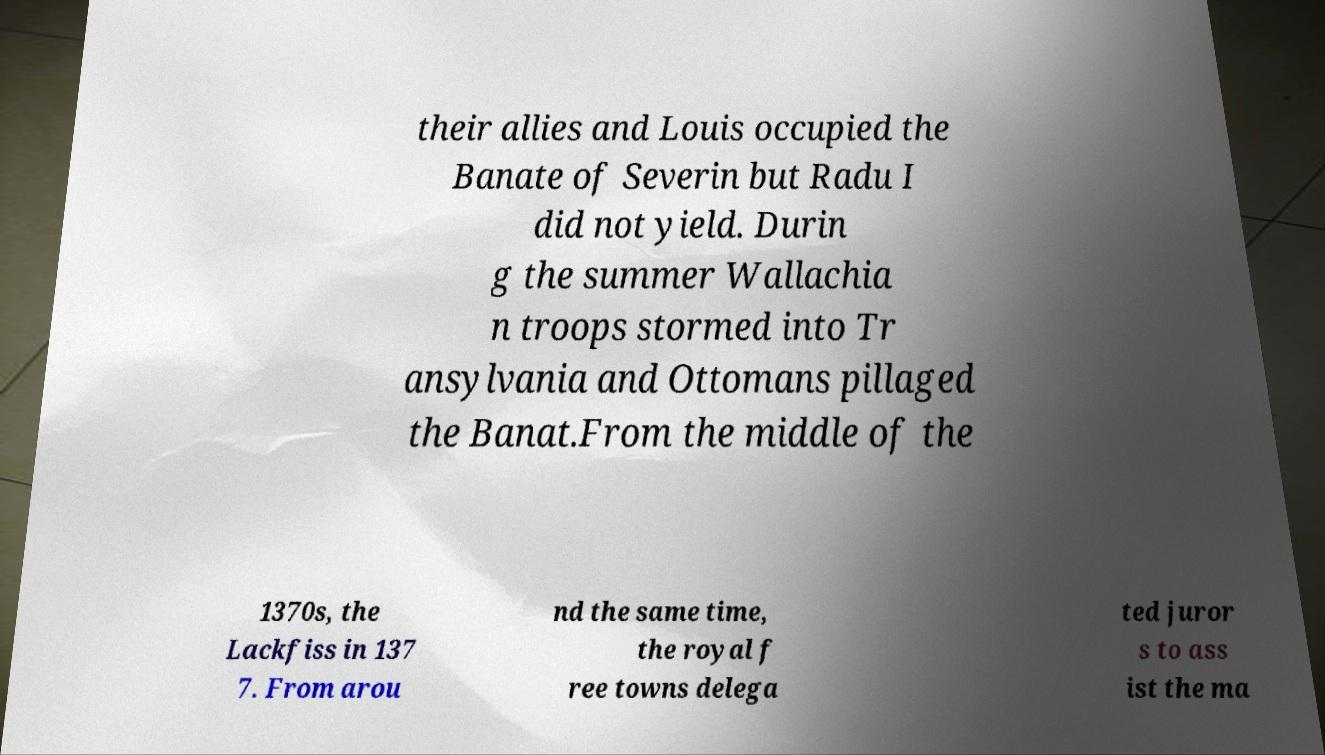Can you accurately transcribe the text from the provided image for me? their allies and Louis occupied the Banate of Severin but Radu I did not yield. Durin g the summer Wallachia n troops stormed into Tr ansylvania and Ottomans pillaged the Banat.From the middle of the 1370s, the Lackfiss in 137 7. From arou nd the same time, the royal f ree towns delega ted juror s to ass ist the ma 